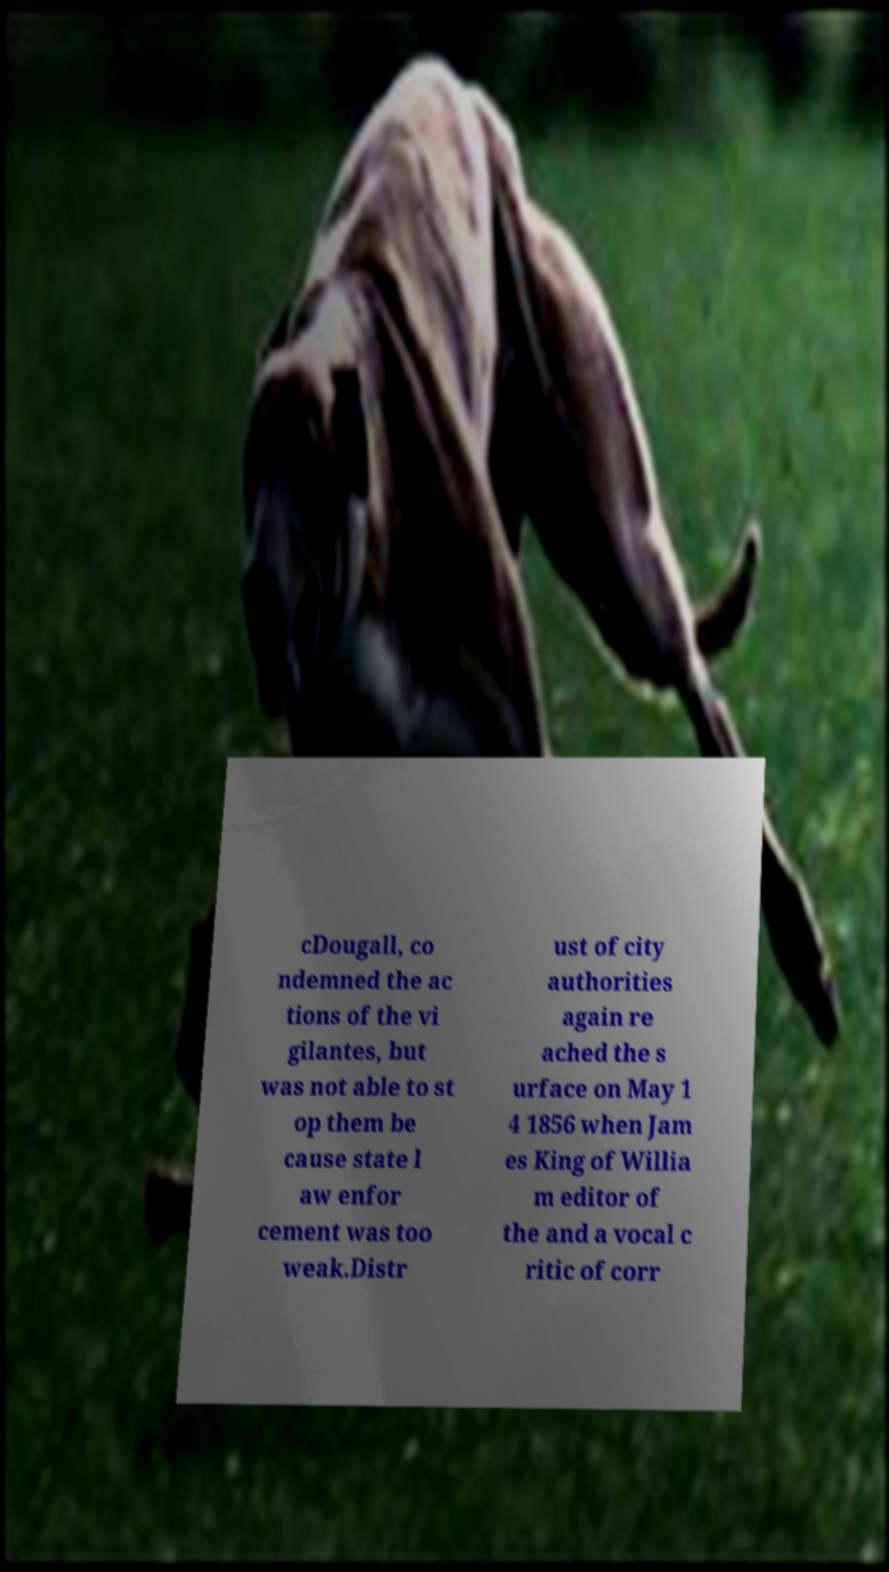There's text embedded in this image that I need extracted. Can you transcribe it verbatim? cDougall, co ndemned the ac tions of the vi gilantes, but was not able to st op them be cause state l aw enfor cement was too weak.Distr ust of city authorities again re ached the s urface on May 1 4 1856 when Jam es King of Willia m editor of the and a vocal c ritic of corr 